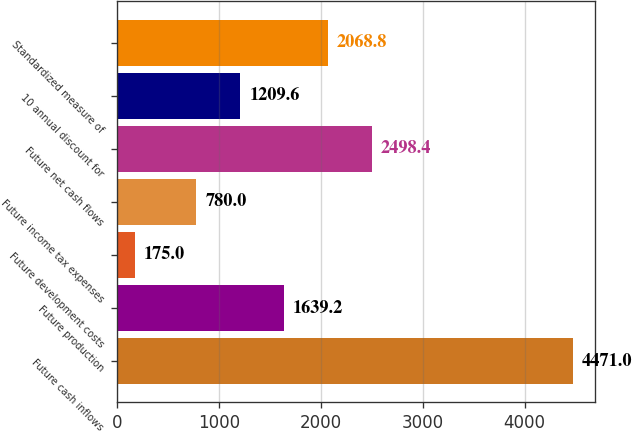Convert chart to OTSL. <chart><loc_0><loc_0><loc_500><loc_500><bar_chart><fcel>Future cash inflows<fcel>Future production<fcel>Future development costs<fcel>Future income tax expenses<fcel>Future net cash flows<fcel>10 annual discount for<fcel>Standardized measure of<nl><fcel>4471<fcel>1639.2<fcel>175<fcel>780<fcel>2498.4<fcel>1209.6<fcel>2068.8<nl></chart> 